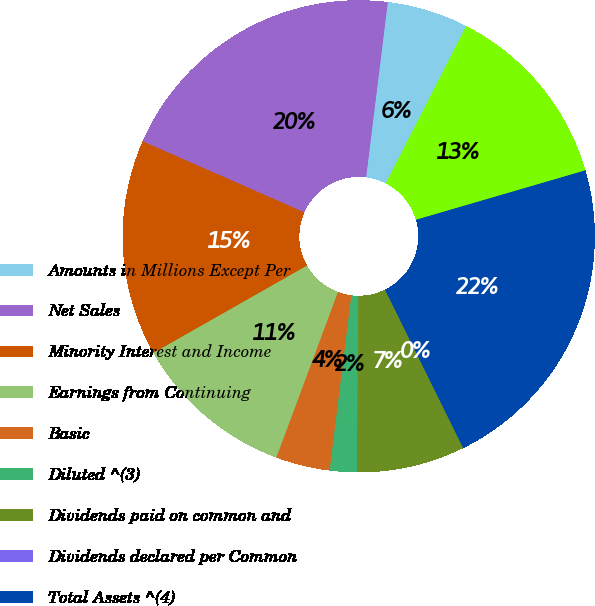Convert chart. <chart><loc_0><loc_0><loc_500><loc_500><pie_chart><fcel>Amounts in Millions Except Per<fcel>Net Sales<fcel>Minority Interest and Income<fcel>Earnings from Continuing<fcel>Basic<fcel>Diluted ^(3)<fcel>Dividends paid on common and<fcel>Dividends declared per Common<fcel>Total Assets ^(4)<fcel>Cash and cash equivalents<nl><fcel>5.56%<fcel>20.37%<fcel>14.81%<fcel>11.11%<fcel>3.7%<fcel>1.85%<fcel>7.41%<fcel>0.0%<fcel>22.22%<fcel>12.96%<nl></chart> 